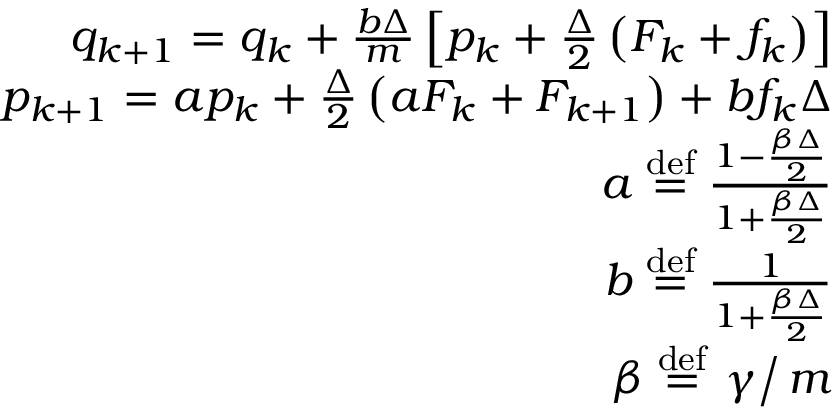<formula> <loc_0><loc_0><loc_500><loc_500>\begin{array} { r } { q _ { k + 1 } = q _ { k } + \frac { b \Delta } { m } \left [ p _ { k } + \frac { \Delta } { 2 } \left ( F _ { k } + f _ { k } \right ) \right ] } \\ { p _ { k + 1 } = a p _ { k } + \frac { \Delta } { 2 } \left ( a F _ { k } + F _ { k + 1 } \right ) + b f _ { k } \Delta } \\ { a \stackrel { d e f } { = } \frac { 1 - \frac { \beta \Delta } { 2 } } { 1 + \frac { \beta \Delta } { 2 } } } \\ { b \stackrel { d e f } { = } \frac { 1 } { 1 + \frac { \beta \Delta } { 2 } } } \\ { \beta \stackrel { d e f } { = } \gamma \right / m } \end{array}</formula> 